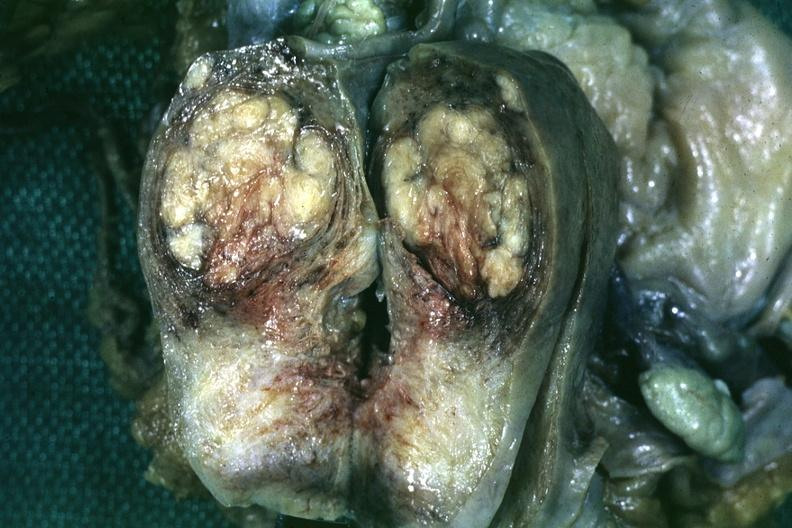does this image show fixed tissue saggital section of organ with bosselated myoma?
Answer the question using a single word or phrase. Yes 